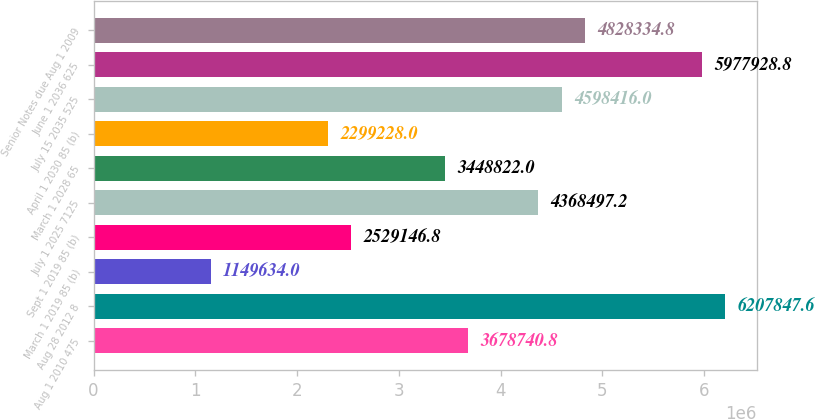Convert chart to OTSL. <chart><loc_0><loc_0><loc_500><loc_500><bar_chart><fcel>Aug 1 2010 475<fcel>Aug 28 2012 8<fcel>March 1 2019 85 (b)<fcel>Sept 1 2019 85 (b)<fcel>July 1 2025 7125<fcel>March 1 2028 65<fcel>April 1 2030 85 (b)<fcel>July 15 2035 525<fcel>June 1 2036 625<fcel>Senior Notes due Aug 1 2009<nl><fcel>3.67874e+06<fcel>6.20785e+06<fcel>1.14963e+06<fcel>2.52915e+06<fcel>4.3685e+06<fcel>3.44882e+06<fcel>2.29923e+06<fcel>4.59842e+06<fcel>5.97793e+06<fcel>4.82833e+06<nl></chart> 